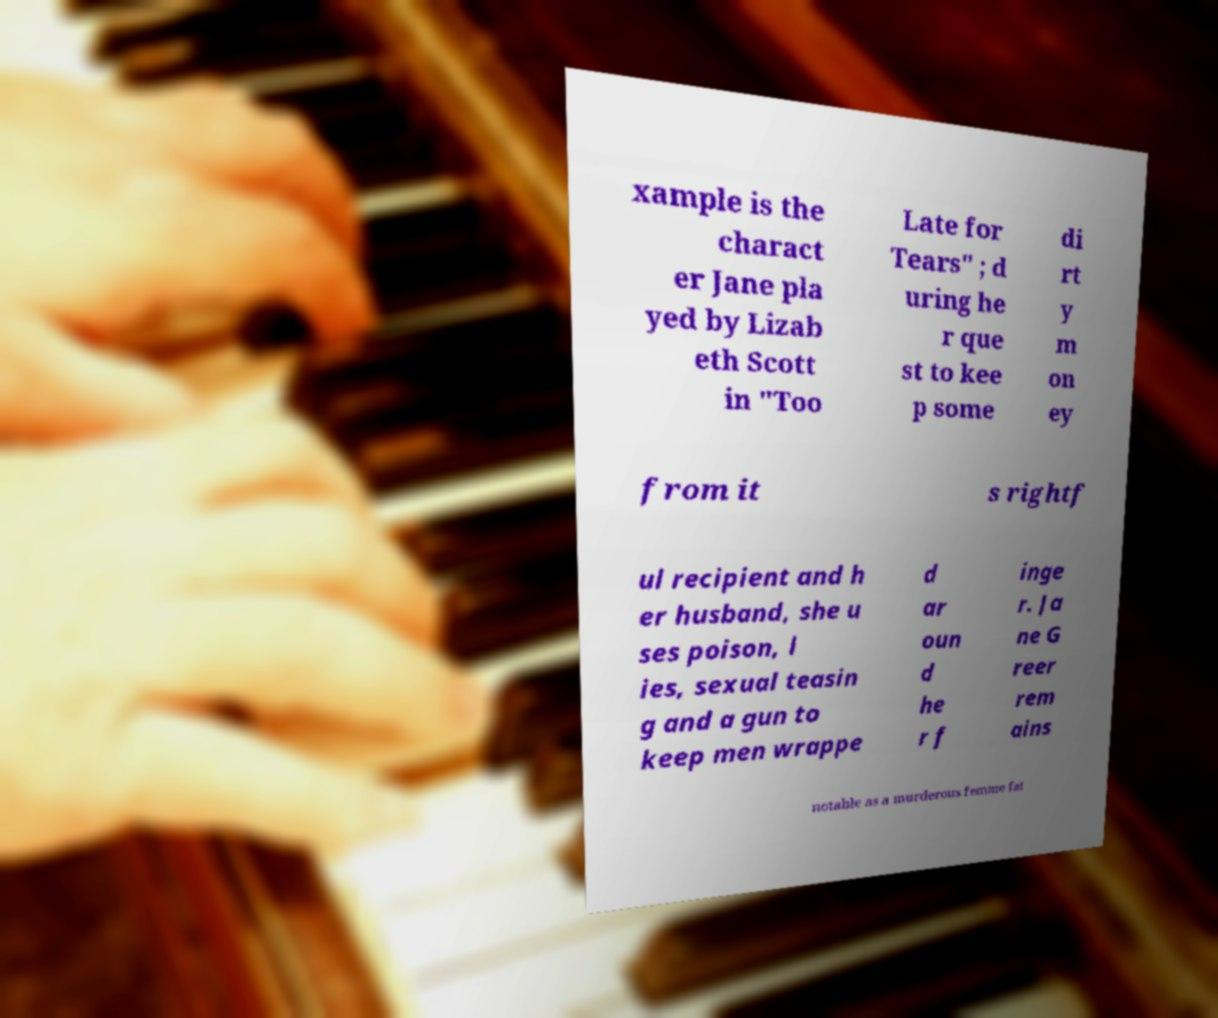Can you accurately transcribe the text from the provided image for me? xample is the charact er Jane pla yed by Lizab eth Scott in "Too Late for Tears" ; d uring he r que st to kee p some di rt y m on ey from it s rightf ul recipient and h er husband, she u ses poison, l ies, sexual teasin g and a gun to keep men wrappe d ar oun d he r f inge r. Ja ne G reer rem ains notable as a murderous femme fat 